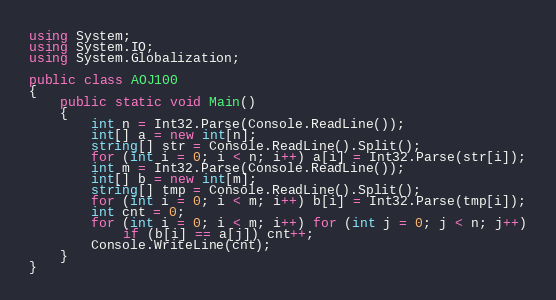<code> <loc_0><loc_0><loc_500><loc_500><_C#_>using System;
using System.IO;
using System.Globalization;

public class AOJ100
{
    public static void Main()
    {
        int n = Int32.Parse(Console.ReadLine());
        int[] a = new int[n];
        string[] str = Console.ReadLine().Split();
        for (int i = 0; i < n; i++) a[i] = Int32.Parse(str[i]);
        int m = Int32.Parse(Console.ReadLine());
        int[] b = new int[m];
        string[] tmp = Console.ReadLine().Split();
        for (int i = 0; i < m; i++) b[i] = Int32.Parse(tmp[i]);
        int cnt = 0;
        for (int i = 0; i < m; i++) for (int j = 0; j < n; j++)
            if (b[i] == a[j]) cnt++;
        Console.WriteLine(cnt);
    }
}</code> 